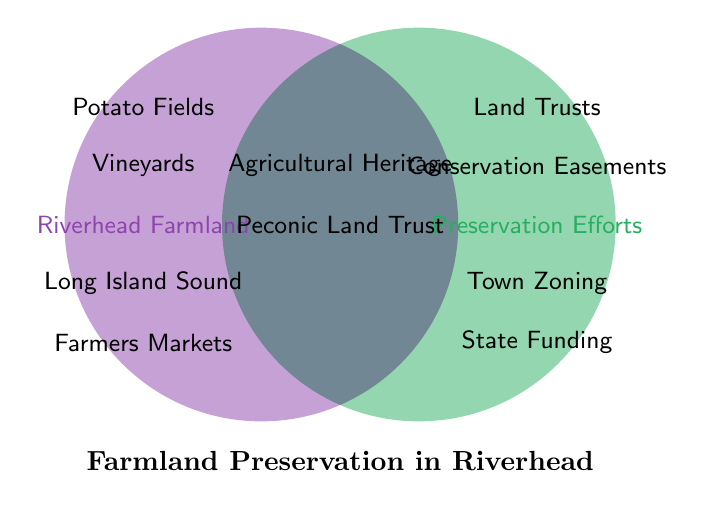What is the title of the figure? The title of the figure is the bold text centered at the bottom.
Answer: Farmland Preservation in Riverhead What entities fall under both Riverhead Farmland and Preservation Efforts? The entities in the intersection of the two circles belong to both categories.
Answer: Agricultural Heritage, Peconic Land Trust Which category includes Town Zoning Regulations? Find the text next to one of the two sets; if it's on the right side, it belongs to Preservation Efforts.
Answer: Preservation Efforts Which items are unique to Riverhead Farmland? Look at the text on the left side inside only the Riverhead Farmland circle.
Answer: Potato Fields, Vineyards, Long Island Sound, Farmers Markets Identify all the preservation initiatives listed in the figure. Summarize the entities in the Preservation Efforts circle and the intersection.
Answer: Land Trusts, Conservation Easements, Peconic Land Trust, Town Zoning Regulations, State Funding Programs How many preservation efforts overlap with Riverhead Farmland? Count the entities located in the intersection of the circles.
Answer: 3 What's common between Agricultural Heritage and Peconic Land Trust? Locate both entities and see that they appear in the intersection, meaning they belong to both categories.
Answer: Both efforts overlap in both sets Compare the number of entities unique to Riverhead Farmland versus those unique to Preservation Efforts. Count and compare each side's non-overlapping entries; four for Riverhead Farmland and four for Preservation Efforts.
Answer: Equal: 4 each What is the shared conservation organization between the two sets? Identify the common term in the intersection referencing conservation.
Answer: Peconic Land Trust Relate Long Island Sound to preservation efforts based on the figure. Long Island Sound appears only in the Riverhead Farmland set and not associated with Preservation Efforts.
Answer: Not related 